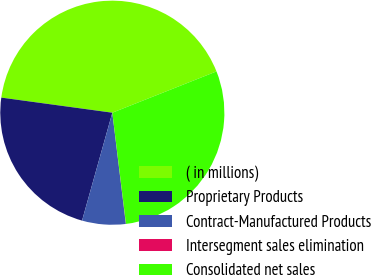Convert chart to OTSL. <chart><loc_0><loc_0><loc_500><loc_500><pie_chart><fcel>( in millions)<fcel>Proprietary Products<fcel>Contract-Manufactured Products<fcel>Intersegment sales elimination<fcel>Consolidated net sales<nl><fcel>41.84%<fcel>22.8%<fcel>6.28%<fcel>0.02%<fcel>29.06%<nl></chart> 